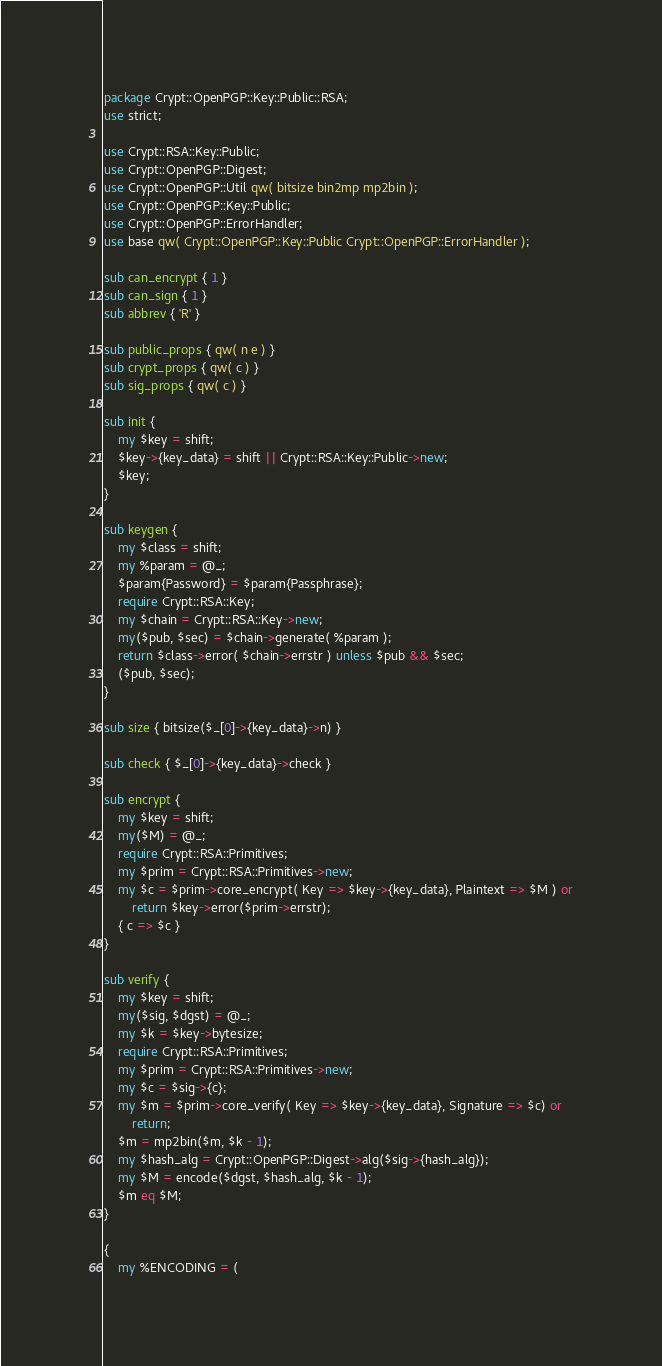<code> <loc_0><loc_0><loc_500><loc_500><_Perl_>package Crypt::OpenPGP::Key::Public::RSA;
use strict;

use Crypt::RSA::Key::Public;
use Crypt::OpenPGP::Digest;
use Crypt::OpenPGP::Util qw( bitsize bin2mp mp2bin );
use Crypt::OpenPGP::Key::Public;
use Crypt::OpenPGP::ErrorHandler;
use base qw( Crypt::OpenPGP::Key::Public Crypt::OpenPGP::ErrorHandler );

sub can_encrypt { 1 }
sub can_sign { 1 }
sub abbrev { 'R' }

sub public_props { qw( n e ) }
sub crypt_props { qw( c ) }
sub sig_props { qw( c ) }

sub init {
    my $key = shift;
    $key->{key_data} = shift || Crypt::RSA::Key::Public->new;
    $key;
}

sub keygen {
    my $class = shift;
    my %param = @_;
    $param{Password} = $param{Passphrase};
    require Crypt::RSA::Key;
    my $chain = Crypt::RSA::Key->new;
    my($pub, $sec) = $chain->generate( %param );
    return $class->error( $chain->errstr ) unless $pub && $sec;
    ($pub, $sec);
}

sub size { bitsize($_[0]->{key_data}->n) }

sub check { $_[0]->{key_data}->check }

sub encrypt {
    my $key = shift;
    my($M) = @_;
    require Crypt::RSA::Primitives;
    my $prim = Crypt::RSA::Primitives->new;
    my $c = $prim->core_encrypt( Key => $key->{key_data}, Plaintext => $M ) or
        return $key->error($prim->errstr);
    { c => $c }
}

sub verify {
    my $key = shift;
    my($sig, $dgst) = @_;
    my $k = $key->bytesize;
    require Crypt::RSA::Primitives;
    my $prim = Crypt::RSA::Primitives->new;
    my $c = $sig->{c};
    my $m = $prim->core_verify( Key => $key->{key_data}, Signature => $c) or
        return;
    $m = mp2bin($m, $k - 1);
    my $hash_alg = Crypt::OpenPGP::Digest->alg($sig->{hash_alg});
    my $M = encode($dgst, $hash_alg, $k - 1);
    $m eq $M;
}

{
    my %ENCODING = (</code> 